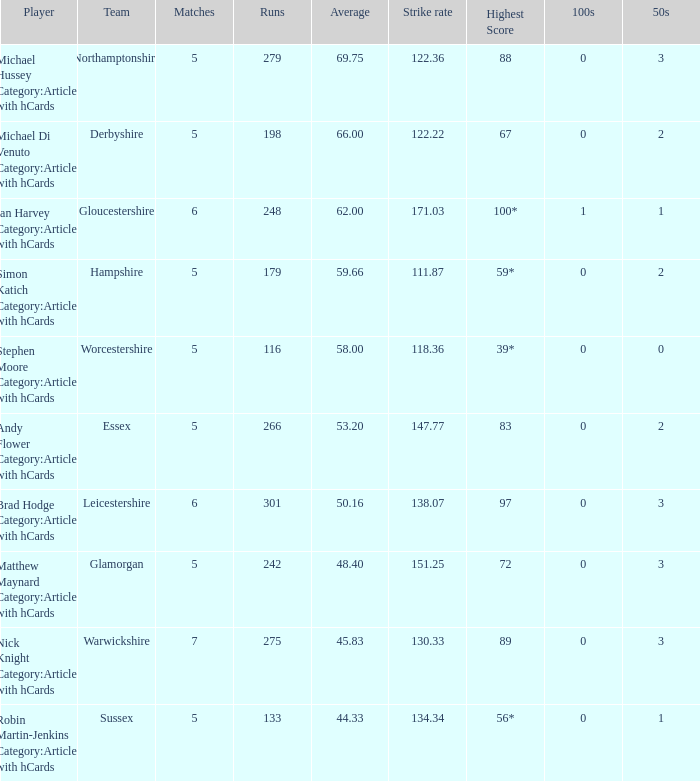If the team is Worcestershire and the Matched had were 5, what is the highest score? 39*. 